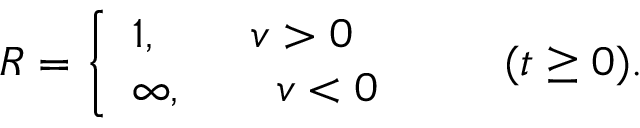Convert formula to latex. <formula><loc_0><loc_0><loc_500><loc_500>R = \left \{ \begin{array} { l } { 1 , \quad v > 0 } \\ { \infty , \quad v < 0 } \end{array} \quad ( t \geq 0 ) .</formula> 